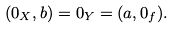Convert formula to latex. <formula><loc_0><loc_0><loc_500><loc_500>( 0 _ { X } , b ) = 0 _ { Y } = ( a , 0 _ { f } ) .</formula> 